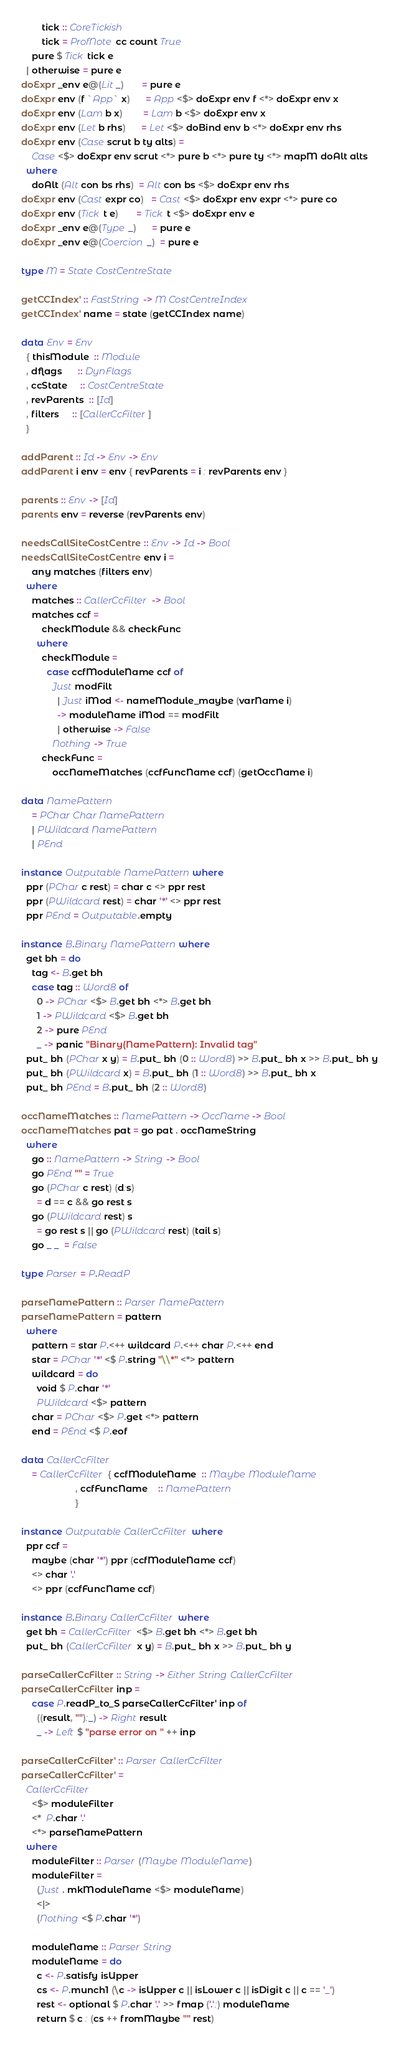<code> <loc_0><loc_0><loc_500><loc_500><_Haskell_>        tick :: CoreTickish
        tick = ProfNote cc count True
    pure $ Tick tick e
  | otherwise = pure e
doExpr _env e@(Lit _)       = pure e
doExpr env (f `App` x)      = App <$> doExpr env f <*> doExpr env x
doExpr env (Lam b x)        = Lam b <$> doExpr env x
doExpr env (Let b rhs)      = Let <$> doBind env b <*> doExpr env rhs
doExpr env (Case scrut b ty alts) =
    Case <$> doExpr env scrut <*> pure b <*> pure ty <*> mapM doAlt alts
  where
    doAlt (Alt con bs rhs)  = Alt con bs <$> doExpr env rhs
doExpr env (Cast expr co)   = Cast <$> doExpr env expr <*> pure co
doExpr env (Tick t e)       = Tick t <$> doExpr env e
doExpr _env e@(Type _)      = pure e
doExpr _env e@(Coercion _)  = pure e

type M = State CostCentreState

getCCIndex' :: FastString -> M CostCentreIndex
getCCIndex' name = state (getCCIndex name)

data Env = Env
  { thisModule  :: Module
  , dflags      :: DynFlags
  , ccState     :: CostCentreState
  , revParents  :: [Id]
  , filters     :: [CallerCcFilter]
  }

addParent :: Id -> Env -> Env
addParent i env = env { revParents = i : revParents env }

parents :: Env -> [Id]
parents env = reverse (revParents env)

needsCallSiteCostCentre :: Env -> Id -> Bool
needsCallSiteCostCentre env i =
    any matches (filters env)
  where
    matches :: CallerCcFilter -> Bool
    matches ccf =
        checkModule && checkFunc
      where
        checkModule =
          case ccfModuleName ccf of
            Just modFilt
              | Just iMod <- nameModule_maybe (varName i)
              -> moduleName iMod == modFilt
              | otherwise -> False
            Nothing -> True
        checkFunc =
            occNameMatches (ccfFuncName ccf) (getOccName i)

data NamePattern
    = PChar Char NamePattern
    | PWildcard NamePattern
    | PEnd

instance Outputable NamePattern where
  ppr (PChar c rest) = char c <> ppr rest
  ppr (PWildcard rest) = char '*' <> ppr rest
  ppr PEnd = Outputable.empty

instance B.Binary NamePattern where
  get bh = do
    tag <- B.get bh
    case tag :: Word8 of
      0 -> PChar <$> B.get bh <*> B.get bh
      1 -> PWildcard <$> B.get bh
      2 -> pure PEnd
      _ -> panic "Binary(NamePattern): Invalid tag"
  put_ bh (PChar x y) = B.put_ bh (0 :: Word8) >> B.put_ bh x >> B.put_ bh y
  put_ bh (PWildcard x) = B.put_ bh (1 :: Word8) >> B.put_ bh x
  put_ bh PEnd = B.put_ bh (2 :: Word8)

occNameMatches :: NamePattern -> OccName -> Bool
occNameMatches pat = go pat . occNameString
  where
    go :: NamePattern -> String -> Bool
    go PEnd "" = True
    go (PChar c rest) (d:s)
      = d == c && go rest s
    go (PWildcard rest) s
      = go rest s || go (PWildcard rest) (tail s)
    go _ _  = False

type Parser = P.ReadP

parseNamePattern :: Parser NamePattern
parseNamePattern = pattern
  where
    pattern = star P.<++ wildcard P.<++ char P.<++ end
    star = PChar '*' <$ P.string "\\*" <*> pattern
    wildcard = do
      void $ P.char '*'
      PWildcard <$> pattern
    char = PChar <$> P.get <*> pattern
    end = PEnd <$ P.eof

data CallerCcFilter
    = CallerCcFilter { ccfModuleName  :: Maybe ModuleName
                     , ccfFuncName    :: NamePattern
                     }

instance Outputable CallerCcFilter where
  ppr ccf =
    maybe (char '*') ppr (ccfModuleName ccf)
    <> char '.'
    <> ppr (ccfFuncName ccf)

instance B.Binary CallerCcFilter where
  get bh = CallerCcFilter <$> B.get bh <*> B.get bh
  put_ bh (CallerCcFilter x y) = B.put_ bh x >> B.put_ bh y

parseCallerCcFilter :: String -> Either String CallerCcFilter
parseCallerCcFilter inp =
    case P.readP_to_S parseCallerCcFilter' inp of
      ((result, ""):_) -> Right result
      _ -> Left $ "parse error on " ++ inp

parseCallerCcFilter' :: Parser CallerCcFilter
parseCallerCcFilter' =
  CallerCcFilter
    <$> moduleFilter
    <*  P.char '.'
    <*> parseNamePattern
  where
    moduleFilter :: Parser (Maybe ModuleName)
    moduleFilter =
      (Just . mkModuleName <$> moduleName)
      <|>
      (Nothing <$ P.char '*')

    moduleName :: Parser String
    moduleName = do
      c <- P.satisfy isUpper
      cs <- P.munch1 (\c -> isUpper c || isLower c || isDigit c || c == '_')
      rest <- optional $ P.char '.' >> fmap ('.':) moduleName
      return $ c : (cs ++ fromMaybe "" rest)

</code> 